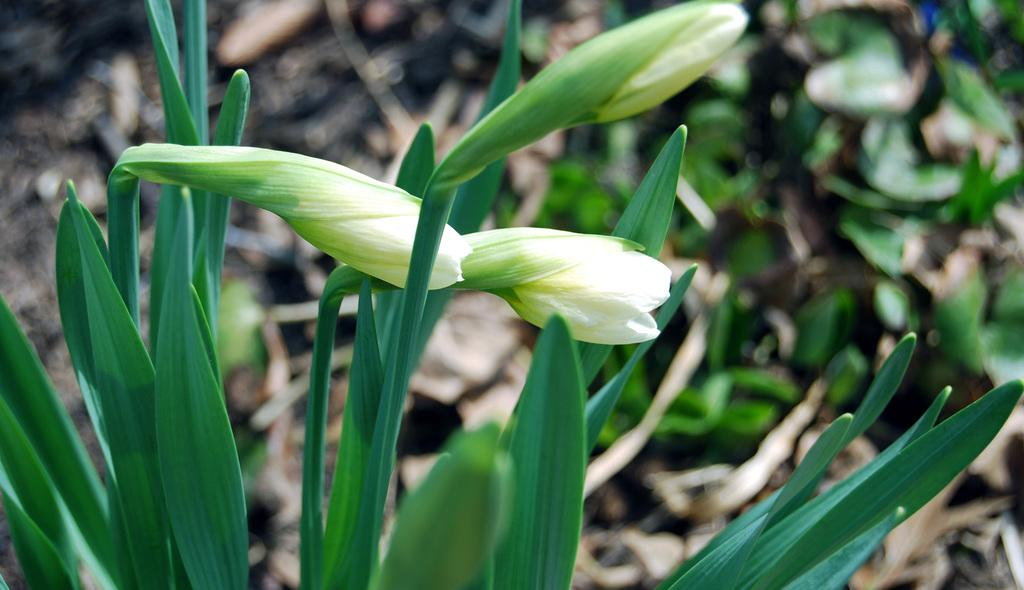What type of living organisms can be seen in the image? Plants and flowers are visible in the image. Can you describe the flowers in the image? The flowers are part of the plants in the image. How many goldfish can be seen swimming in the image? There are no goldfish present in the image; it features plants and flowers. What type of cloud is visible in the image? There is no cloud visible in the image; it features plants and flowers. 